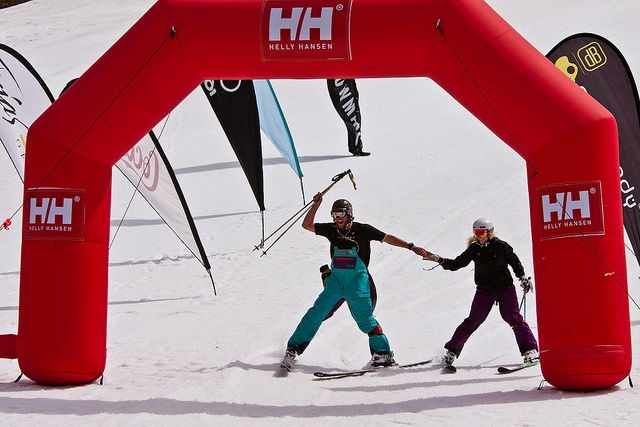Describe the objects in this image and their specific colors. I can see people in maroon, black, teal, and gray tones, people in maroon, black, lightgray, gray, and darkgray tones, skis in maroon, lightgray, darkgray, black, and gray tones, and skis in maroon, black, gray, green, and darkgray tones in this image. 